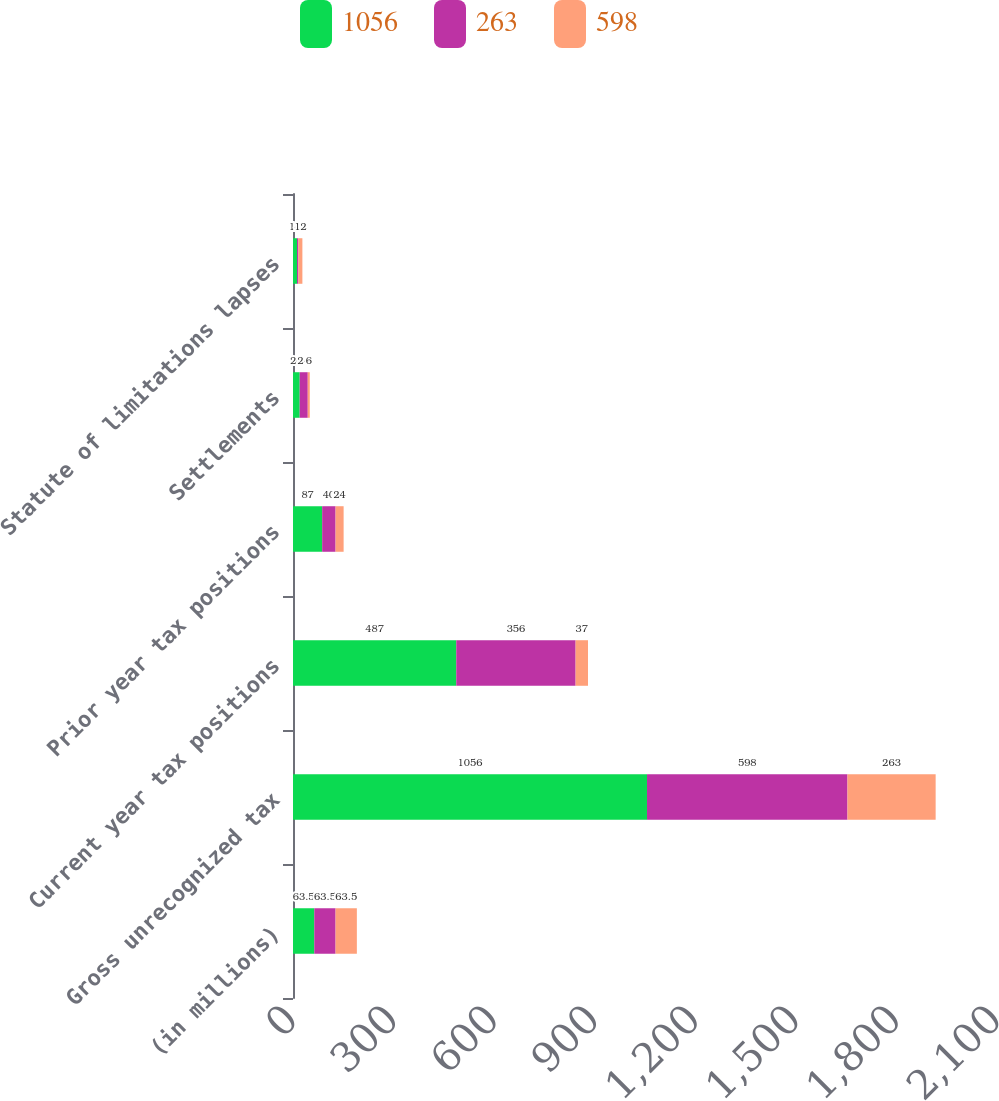Convert chart to OTSL. <chart><loc_0><loc_0><loc_500><loc_500><stacked_bar_chart><ecel><fcel>(in millions)<fcel>Gross unrecognized tax<fcel>Current year tax positions<fcel>Prior year tax positions<fcel>Settlements<fcel>Statute of limitations lapses<nl><fcel>1056<fcel>63.5<fcel>1056<fcel>487<fcel>87<fcel>20<fcel>12<nl><fcel>263<fcel>63.5<fcel>598<fcel>356<fcel>40<fcel>24<fcel>4<nl><fcel>598<fcel>63.5<fcel>263<fcel>37<fcel>24<fcel>6<fcel>12<nl></chart> 